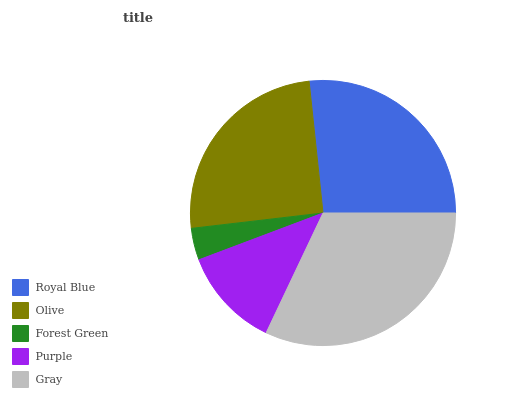Is Forest Green the minimum?
Answer yes or no. Yes. Is Gray the maximum?
Answer yes or no. Yes. Is Olive the minimum?
Answer yes or no. No. Is Olive the maximum?
Answer yes or no. No. Is Royal Blue greater than Olive?
Answer yes or no. Yes. Is Olive less than Royal Blue?
Answer yes or no. Yes. Is Olive greater than Royal Blue?
Answer yes or no. No. Is Royal Blue less than Olive?
Answer yes or no. No. Is Olive the high median?
Answer yes or no. Yes. Is Olive the low median?
Answer yes or no. Yes. Is Royal Blue the high median?
Answer yes or no. No. Is Royal Blue the low median?
Answer yes or no. No. 